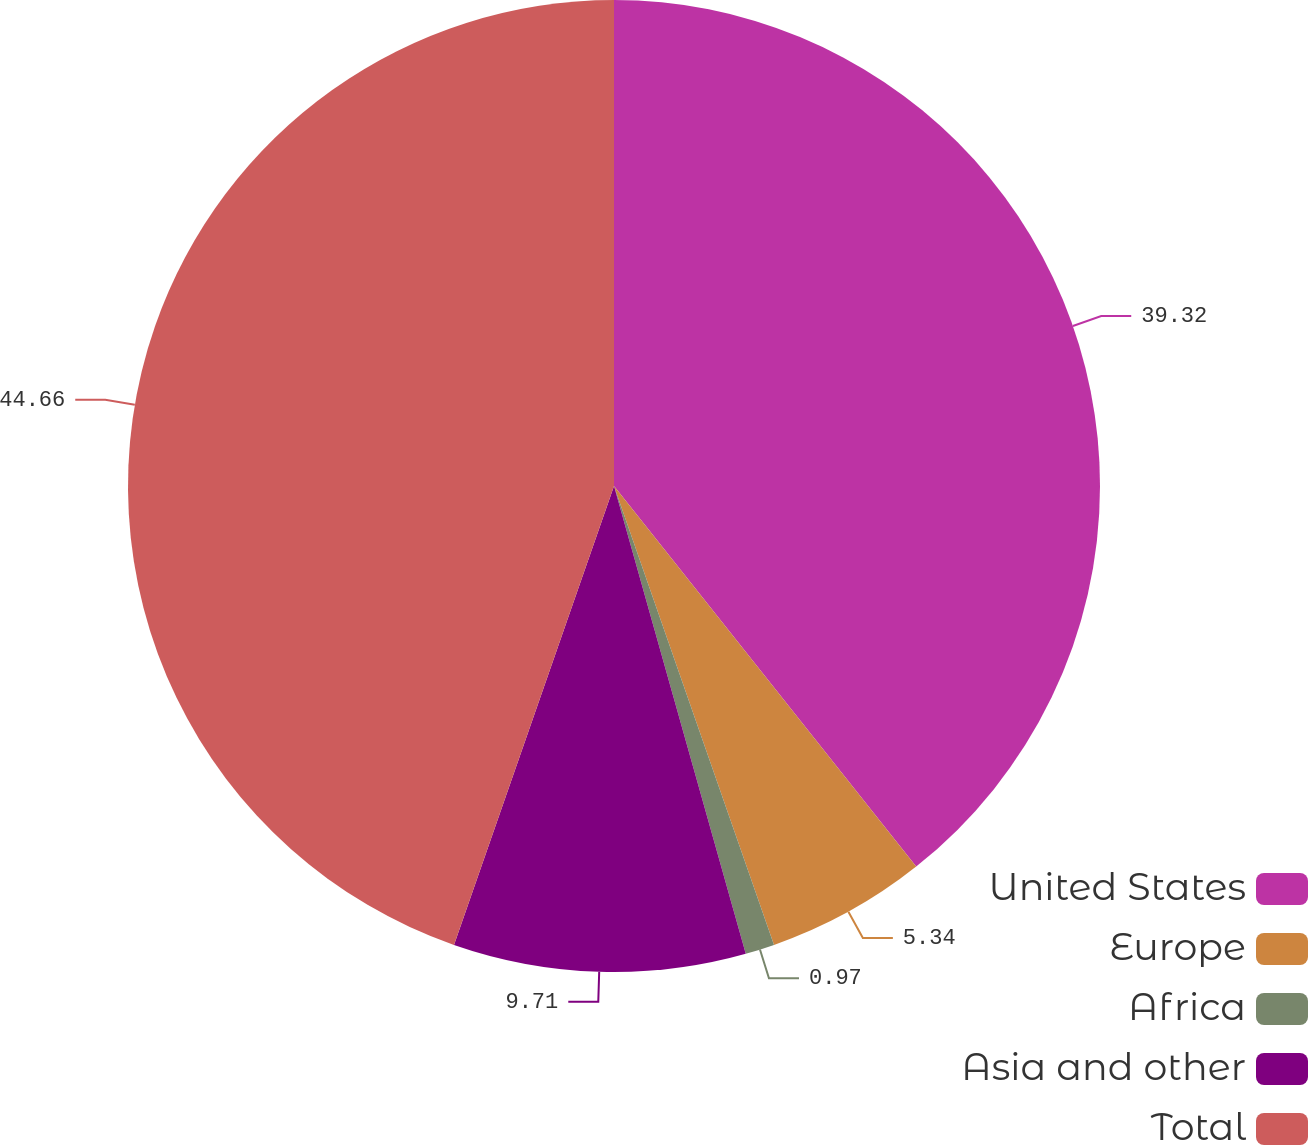Convert chart. <chart><loc_0><loc_0><loc_500><loc_500><pie_chart><fcel>United States<fcel>Europe<fcel>Africa<fcel>Asia and other<fcel>Total<nl><fcel>39.32%<fcel>5.34%<fcel>0.97%<fcel>9.71%<fcel>44.66%<nl></chart> 